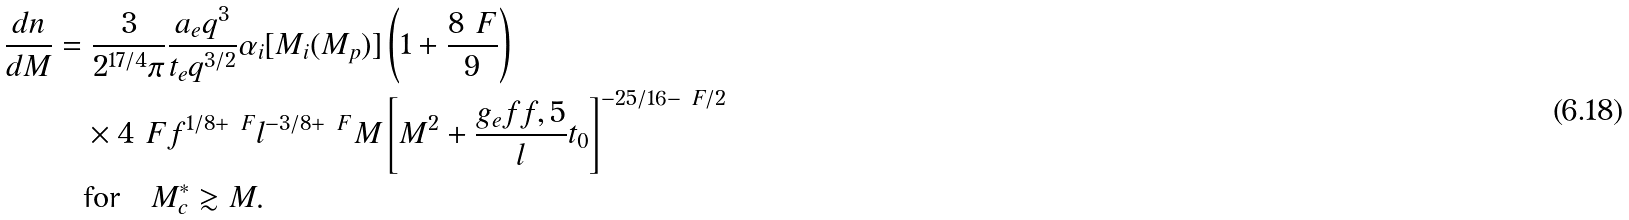Convert formula to latex. <formula><loc_0><loc_0><loc_500><loc_500>\frac { d n } { d M } & = \frac { 3 } { 2 ^ { 1 7 / 4 } \pi } \frac { a _ { e } q ^ { 3 } } { t _ { e } q ^ { 3 / 2 } } \alpha _ { i } [ M _ { i } ( M _ { p } ) ] \left ( 1 + \frac { 8 \ F } { 9 } \right ) \\ & \quad \times 4 ^ { \ } F f ^ { 1 / 8 + \ F } l ^ { - 3 / 8 + \ F } M \left [ M ^ { 2 } + \frac { g _ { e } f f , 5 } { l } t _ { 0 } \right ] ^ { - 2 5 / 1 6 - \ F / 2 } \\ & \quad \text {for} \quad M _ { c } ^ { * } \gtrsim M .</formula> 